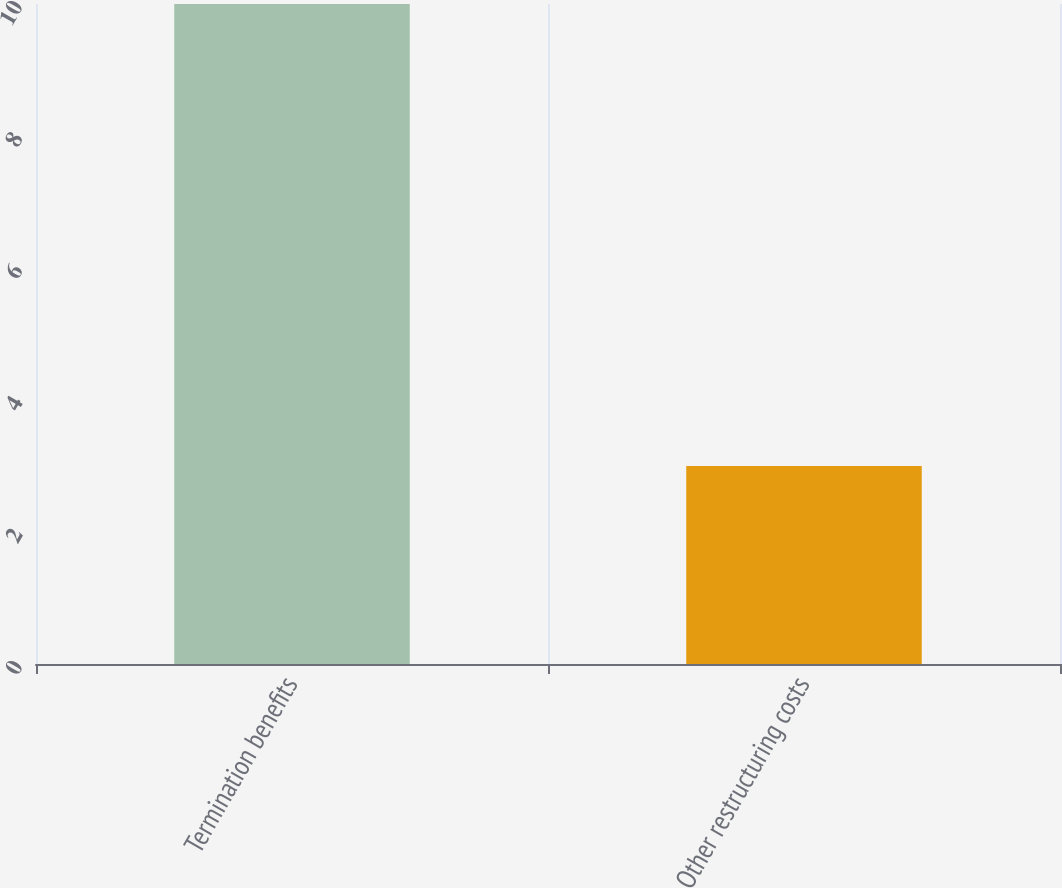Convert chart. <chart><loc_0><loc_0><loc_500><loc_500><bar_chart><fcel>Termination benefits<fcel>Other restructuring costs<nl><fcel>10<fcel>3<nl></chart> 